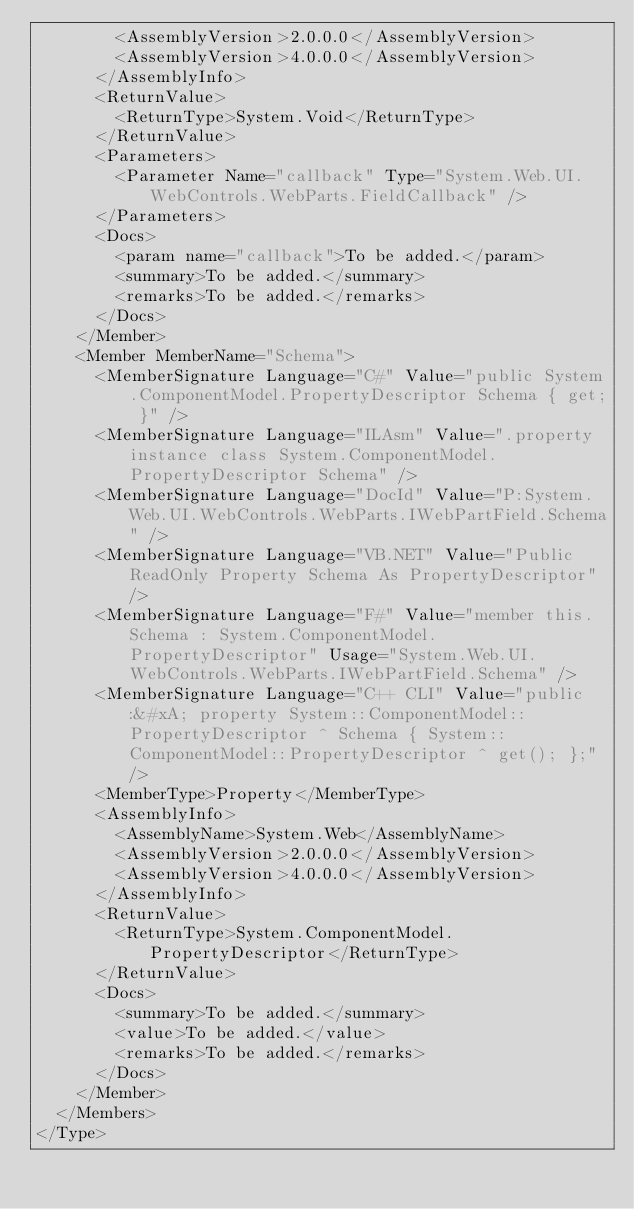<code> <loc_0><loc_0><loc_500><loc_500><_XML_>        <AssemblyVersion>2.0.0.0</AssemblyVersion>
        <AssemblyVersion>4.0.0.0</AssemblyVersion>
      </AssemblyInfo>
      <ReturnValue>
        <ReturnType>System.Void</ReturnType>
      </ReturnValue>
      <Parameters>
        <Parameter Name="callback" Type="System.Web.UI.WebControls.WebParts.FieldCallback" />
      </Parameters>
      <Docs>
        <param name="callback">To be added.</param>
        <summary>To be added.</summary>
        <remarks>To be added.</remarks>
      </Docs>
    </Member>
    <Member MemberName="Schema">
      <MemberSignature Language="C#" Value="public System.ComponentModel.PropertyDescriptor Schema { get; }" />
      <MemberSignature Language="ILAsm" Value=".property instance class System.ComponentModel.PropertyDescriptor Schema" />
      <MemberSignature Language="DocId" Value="P:System.Web.UI.WebControls.WebParts.IWebPartField.Schema" />
      <MemberSignature Language="VB.NET" Value="Public ReadOnly Property Schema As PropertyDescriptor" />
      <MemberSignature Language="F#" Value="member this.Schema : System.ComponentModel.PropertyDescriptor" Usage="System.Web.UI.WebControls.WebParts.IWebPartField.Schema" />
      <MemberSignature Language="C++ CLI" Value="public:&#xA; property System::ComponentModel::PropertyDescriptor ^ Schema { System::ComponentModel::PropertyDescriptor ^ get(); };" />
      <MemberType>Property</MemberType>
      <AssemblyInfo>
        <AssemblyName>System.Web</AssemblyName>
        <AssemblyVersion>2.0.0.0</AssemblyVersion>
        <AssemblyVersion>4.0.0.0</AssemblyVersion>
      </AssemblyInfo>
      <ReturnValue>
        <ReturnType>System.ComponentModel.PropertyDescriptor</ReturnType>
      </ReturnValue>
      <Docs>
        <summary>To be added.</summary>
        <value>To be added.</value>
        <remarks>To be added.</remarks>
      </Docs>
    </Member>
  </Members>
</Type>
</code> 